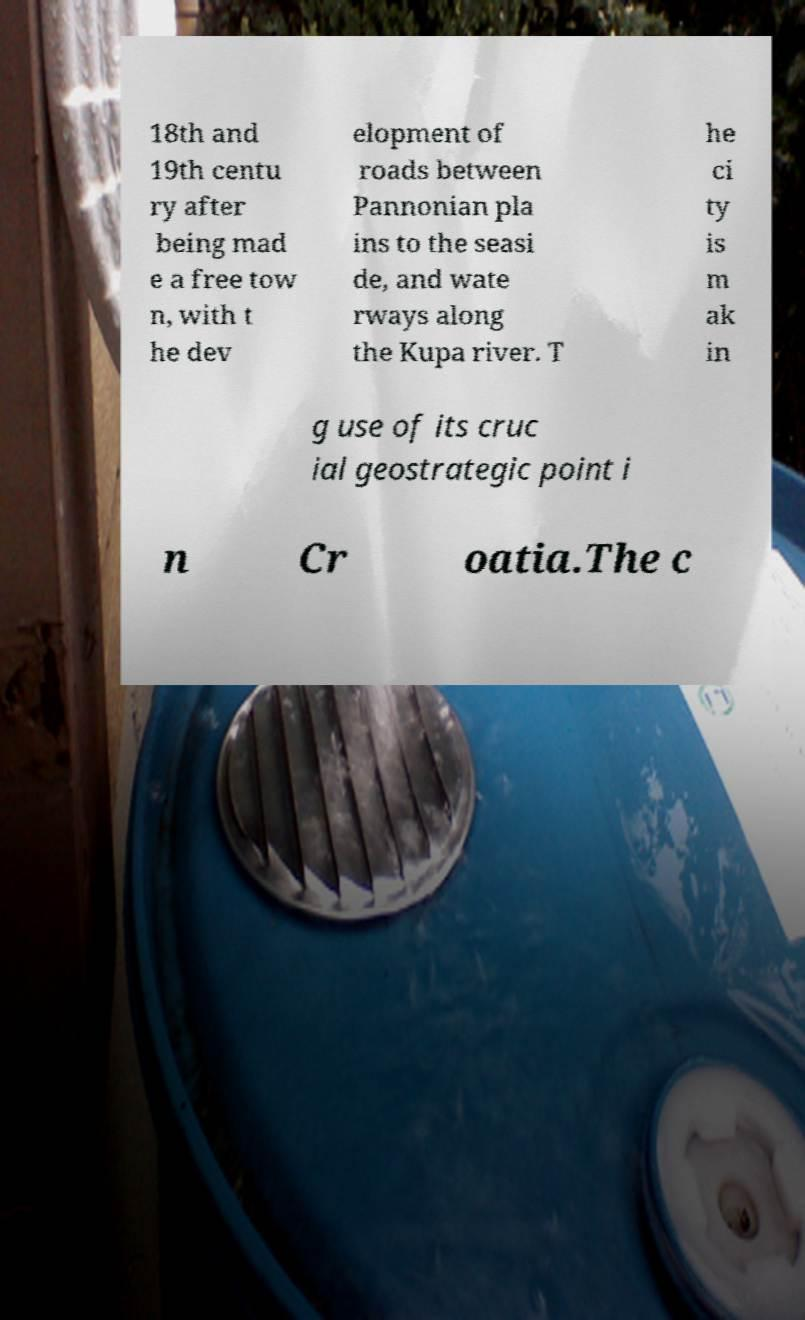Could you assist in decoding the text presented in this image and type it out clearly? 18th and 19th centu ry after being mad e a free tow n, with t he dev elopment of roads between Pannonian pla ins to the seasi de, and wate rways along the Kupa river. T he ci ty is m ak in g use of its cruc ial geostrategic point i n Cr oatia.The c 